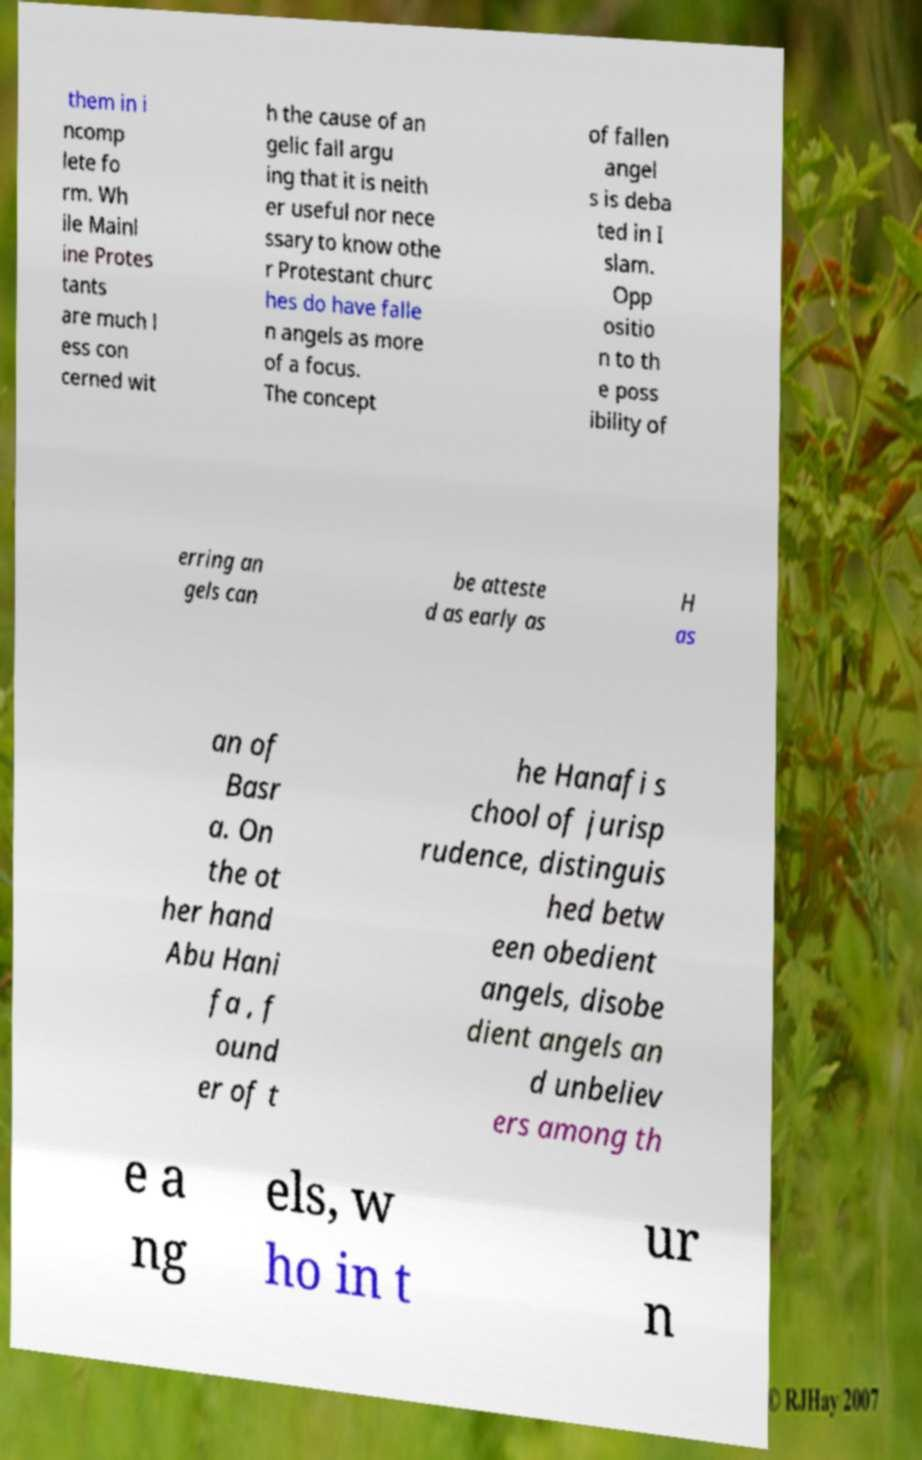Please read and relay the text visible in this image. What does it say? them in i ncomp lete fo rm. Wh ile Mainl ine Protes tants are much l ess con cerned wit h the cause of an gelic fall argu ing that it is neith er useful nor nece ssary to know othe r Protestant churc hes do have falle n angels as more of a focus. The concept of fallen angel s is deba ted in I slam. Opp ositio n to th e poss ibility of erring an gels can be atteste d as early as H as an of Basr a. On the ot her hand Abu Hani fa , f ound er of t he Hanafi s chool of jurisp rudence, distinguis hed betw een obedient angels, disobe dient angels an d unbeliev ers among th e a ng els, w ho in t ur n 